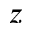<formula> <loc_0><loc_0><loc_500><loc_500>z</formula> 